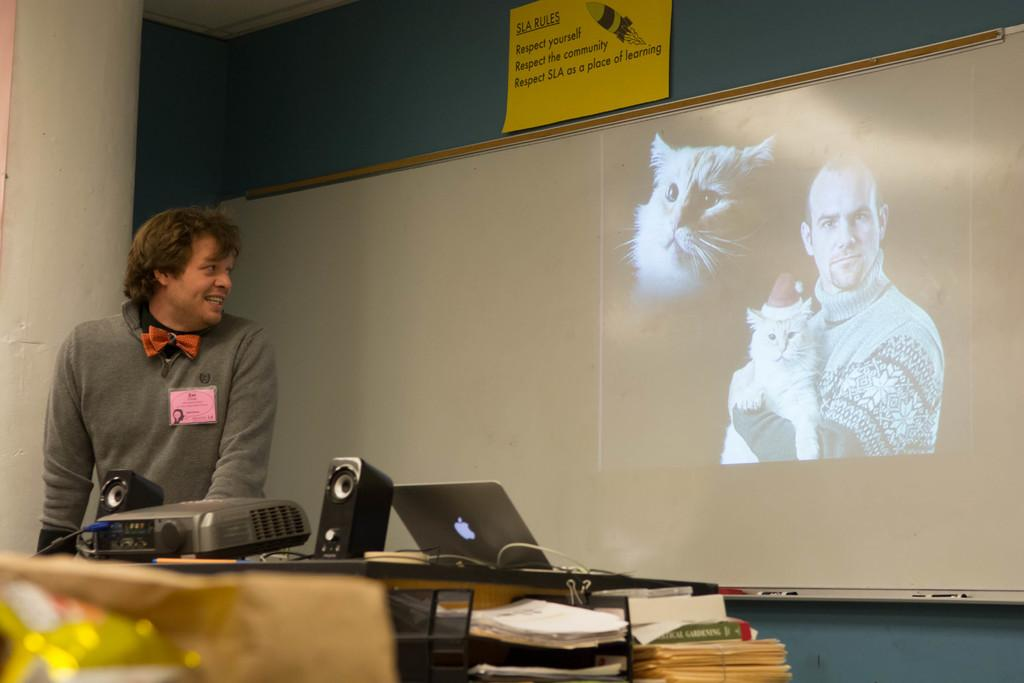<image>
Present a compact description of the photo's key features. An image of a man and two cats is displayed under a sign about three things one needs to respect. 